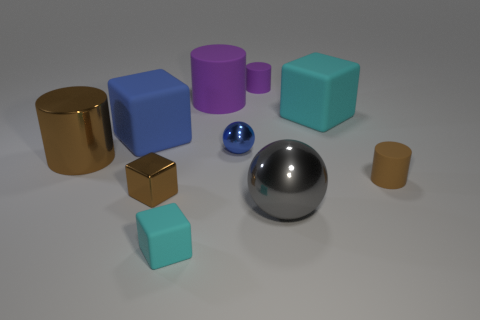Can you describe the different materials and textures present in the objects? Certainly! The objects display a variety of materials and textures. The large sphere and the small blue object seem to have a highly reflective, smooth metallic surface. The brown objects have a matte finish with a texture that could resemble plastics or painted wood. The cyan objects have a smooth, possibly plastic texture, with the larger cube being particularly shiny, indicating a possibly lacquered or polished surface. 